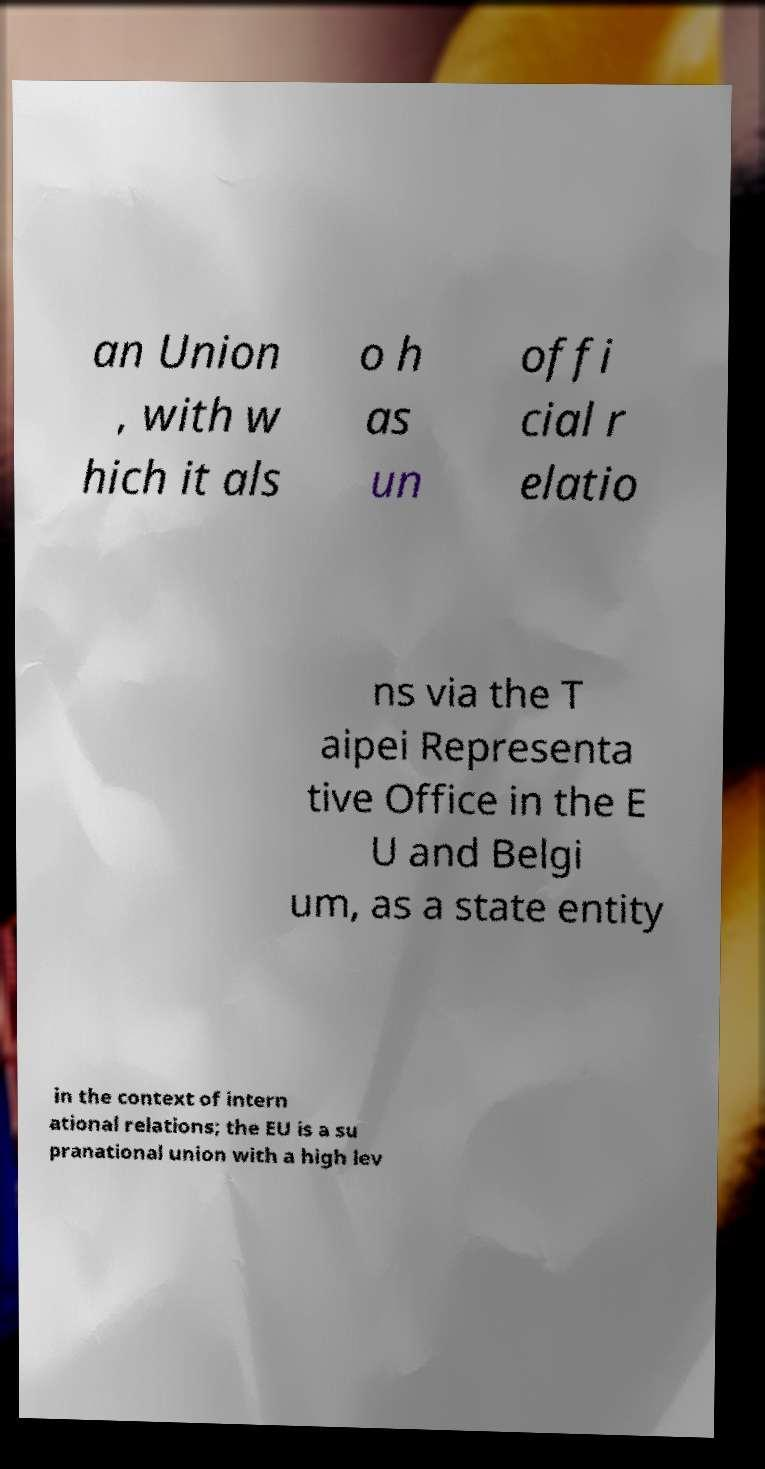Please identify and transcribe the text found in this image. an Union , with w hich it als o h as un offi cial r elatio ns via the T aipei Representa tive Office in the E U and Belgi um, as a state entity in the context of intern ational relations; the EU is a su pranational union with a high lev 